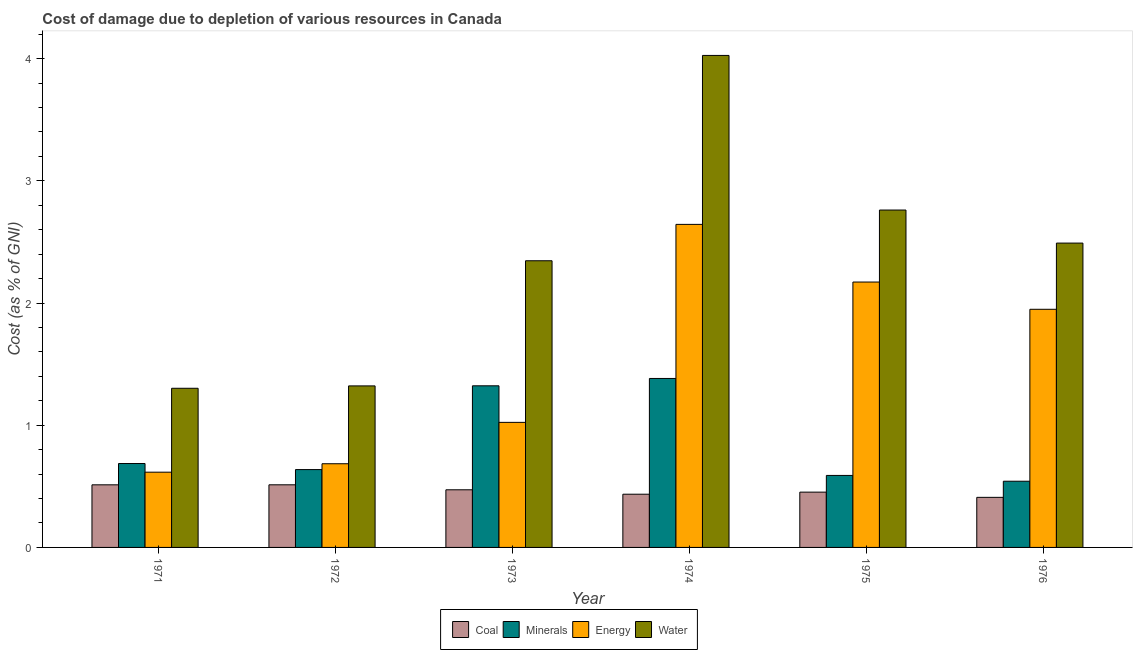How many different coloured bars are there?
Make the answer very short. 4. Are the number of bars on each tick of the X-axis equal?
Offer a very short reply. Yes. How many bars are there on the 1st tick from the left?
Your response must be concise. 4. How many bars are there on the 6th tick from the right?
Make the answer very short. 4. What is the cost of damage due to depletion of energy in 1972?
Offer a terse response. 0.68. Across all years, what is the maximum cost of damage due to depletion of energy?
Give a very brief answer. 2.64. Across all years, what is the minimum cost of damage due to depletion of water?
Provide a short and direct response. 1.3. In which year was the cost of damage due to depletion of energy maximum?
Ensure brevity in your answer.  1974. What is the total cost of damage due to depletion of water in the graph?
Make the answer very short. 14.25. What is the difference between the cost of damage due to depletion of water in 1971 and that in 1974?
Provide a short and direct response. -2.72. What is the difference between the cost of damage due to depletion of coal in 1973 and the cost of damage due to depletion of minerals in 1975?
Your answer should be very brief. 0.02. What is the average cost of damage due to depletion of minerals per year?
Offer a very short reply. 0.86. In the year 1973, what is the difference between the cost of damage due to depletion of water and cost of damage due to depletion of energy?
Make the answer very short. 0. What is the ratio of the cost of damage due to depletion of minerals in 1973 to that in 1974?
Provide a succinct answer. 0.96. What is the difference between the highest and the second highest cost of damage due to depletion of minerals?
Your response must be concise. 0.06. What is the difference between the highest and the lowest cost of damage due to depletion of energy?
Offer a very short reply. 2.03. In how many years, is the cost of damage due to depletion of coal greater than the average cost of damage due to depletion of coal taken over all years?
Make the answer very short. 3. Is the sum of the cost of damage due to depletion of water in 1973 and 1974 greater than the maximum cost of damage due to depletion of coal across all years?
Offer a terse response. Yes. What does the 1st bar from the left in 1975 represents?
Your answer should be compact. Coal. What does the 3rd bar from the right in 1973 represents?
Your answer should be very brief. Minerals. What is the difference between two consecutive major ticks on the Y-axis?
Offer a very short reply. 1. Are the values on the major ticks of Y-axis written in scientific E-notation?
Keep it short and to the point. No. Does the graph contain grids?
Offer a very short reply. No. How many legend labels are there?
Keep it short and to the point. 4. What is the title of the graph?
Keep it short and to the point. Cost of damage due to depletion of various resources in Canada . What is the label or title of the Y-axis?
Ensure brevity in your answer.  Cost (as % of GNI). What is the Cost (as % of GNI) in Coal in 1971?
Your answer should be compact. 0.51. What is the Cost (as % of GNI) in Minerals in 1971?
Make the answer very short. 0.69. What is the Cost (as % of GNI) in Energy in 1971?
Your response must be concise. 0.62. What is the Cost (as % of GNI) in Water in 1971?
Provide a succinct answer. 1.3. What is the Cost (as % of GNI) in Coal in 1972?
Ensure brevity in your answer.  0.51. What is the Cost (as % of GNI) of Minerals in 1972?
Your answer should be compact. 0.64. What is the Cost (as % of GNI) in Energy in 1972?
Your answer should be very brief. 0.68. What is the Cost (as % of GNI) in Water in 1972?
Provide a succinct answer. 1.32. What is the Cost (as % of GNI) of Coal in 1973?
Ensure brevity in your answer.  0.47. What is the Cost (as % of GNI) in Minerals in 1973?
Give a very brief answer. 1.32. What is the Cost (as % of GNI) of Energy in 1973?
Your answer should be compact. 1.02. What is the Cost (as % of GNI) in Water in 1973?
Offer a very short reply. 2.35. What is the Cost (as % of GNI) in Coal in 1974?
Offer a very short reply. 0.44. What is the Cost (as % of GNI) of Minerals in 1974?
Provide a short and direct response. 1.38. What is the Cost (as % of GNI) of Energy in 1974?
Keep it short and to the point. 2.64. What is the Cost (as % of GNI) in Water in 1974?
Make the answer very short. 4.03. What is the Cost (as % of GNI) in Coal in 1975?
Offer a very short reply. 0.45. What is the Cost (as % of GNI) of Minerals in 1975?
Keep it short and to the point. 0.59. What is the Cost (as % of GNI) in Energy in 1975?
Offer a very short reply. 2.17. What is the Cost (as % of GNI) in Water in 1975?
Ensure brevity in your answer.  2.76. What is the Cost (as % of GNI) in Coal in 1976?
Make the answer very short. 0.41. What is the Cost (as % of GNI) in Minerals in 1976?
Your answer should be very brief. 0.54. What is the Cost (as % of GNI) in Energy in 1976?
Offer a terse response. 1.95. What is the Cost (as % of GNI) of Water in 1976?
Your answer should be compact. 2.49. Across all years, what is the maximum Cost (as % of GNI) of Coal?
Provide a short and direct response. 0.51. Across all years, what is the maximum Cost (as % of GNI) in Minerals?
Ensure brevity in your answer.  1.38. Across all years, what is the maximum Cost (as % of GNI) of Energy?
Provide a succinct answer. 2.64. Across all years, what is the maximum Cost (as % of GNI) in Water?
Your response must be concise. 4.03. Across all years, what is the minimum Cost (as % of GNI) of Coal?
Provide a short and direct response. 0.41. Across all years, what is the minimum Cost (as % of GNI) in Minerals?
Your response must be concise. 0.54. Across all years, what is the minimum Cost (as % of GNI) in Energy?
Your response must be concise. 0.62. Across all years, what is the minimum Cost (as % of GNI) of Water?
Give a very brief answer. 1.3. What is the total Cost (as % of GNI) of Coal in the graph?
Ensure brevity in your answer.  2.79. What is the total Cost (as % of GNI) of Minerals in the graph?
Provide a succinct answer. 5.16. What is the total Cost (as % of GNI) in Energy in the graph?
Provide a succinct answer. 9.09. What is the total Cost (as % of GNI) of Water in the graph?
Offer a very short reply. 14.25. What is the difference between the Cost (as % of GNI) of Coal in 1971 and that in 1972?
Keep it short and to the point. -0. What is the difference between the Cost (as % of GNI) in Minerals in 1971 and that in 1972?
Your answer should be compact. 0.05. What is the difference between the Cost (as % of GNI) of Energy in 1971 and that in 1972?
Ensure brevity in your answer.  -0.07. What is the difference between the Cost (as % of GNI) in Water in 1971 and that in 1972?
Ensure brevity in your answer.  -0.02. What is the difference between the Cost (as % of GNI) in Coal in 1971 and that in 1973?
Offer a terse response. 0.04. What is the difference between the Cost (as % of GNI) in Minerals in 1971 and that in 1973?
Offer a terse response. -0.64. What is the difference between the Cost (as % of GNI) of Energy in 1971 and that in 1973?
Provide a succinct answer. -0.41. What is the difference between the Cost (as % of GNI) in Water in 1971 and that in 1973?
Provide a succinct answer. -1.04. What is the difference between the Cost (as % of GNI) of Coal in 1971 and that in 1974?
Your answer should be compact. 0.08. What is the difference between the Cost (as % of GNI) in Minerals in 1971 and that in 1974?
Give a very brief answer. -0.7. What is the difference between the Cost (as % of GNI) in Energy in 1971 and that in 1974?
Offer a terse response. -2.03. What is the difference between the Cost (as % of GNI) of Water in 1971 and that in 1974?
Keep it short and to the point. -2.72. What is the difference between the Cost (as % of GNI) of Coal in 1971 and that in 1975?
Your answer should be compact. 0.06. What is the difference between the Cost (as % of GNI) in Minerals in 1971 and that in 1975?
Make the answer very short. 0.1. What is the difference between the Cost (as % of GNI) in Energy in 1971 and that in 1975?
Give a very brief answer. -1.56. What is the difference between the Cost (as % of GNI) in Water in 1971 and that in 1975?
Your response must be concise. -1.46. What is the difference between the Cost (as % of GNI) in Coal in 1971 and that in 1976?
Make the answer very short. 0.1. What is the difference between the Cost (as % of GNI) in Minerals in 1971 and that in 1976?
Give a very brief answer. 0.14. What is the difference between the Cost (as % of GNI) of Energy in 1971 and that in 1976?
Your answer should be very brief. -1.33. What is the difference between the Cost (as % of GNI) in Water in 1971 and that in 1976?
Offer a very short reply. -1.19. What is the difference between the Cost (as % of GNI) in Coal in 1972 and that in 1973?
Give a very brief answer. 0.04. What is the difference between the Cost (as % of GNI) of Minerals in 1972 and that in 1973?
Provide a succinct answer. -0.69. What is the difference between the Cost (as % of GNI) of Energy in 1972 and that in 1973?
Give a very brief answer. -0.34. What is the difference between the Cost (as % of GNI) of Water in 1972 and that in 1973?
Provide a succinct answer. -1.02. What is the difference between the Cost (as % of GNI) of Coal in 1972 and that in 1974?
Your response must be concise. 0.08. What is the difference between the Cost (as % of GNI) of Minerals in 1972 and that in 1974?
Your answer should be very brief. -0.75. What is the difference between the Cost (as % of GNI) of Energy in 1972 and that in 1974?
Keep it short and to the point. -1.96. What is the difference between the Cost (as % of GNI) in Water in 1972 and that in 1974?
Your answer should be compact. -2.7. What is the difference between the Cost (as % of GNI) in Coal in 1972 and that in 1975?
Ensure brevity in your answer.  0.06. What is the difference between the Cost (as % of GNI) in Minerals in 1972 and that in 1975?
Your response must be concise. 0.05. What is the difference between the Cost (as % of GNI) of Energy in 1972 and that in 1975?
Keep it short and to the point. -1.49. What is the difference between the Cost (as % of GNI) of Water in 1972 and that in 1975?
Keep it short and to the point. -1.44. What is the difference between the Cost (as % of GNI) in Coal in 1972 and that in 1976?
Ensure brevity in your answer.  0.1. What is the difference between the Cost (as % of GNI) in Minerals in 1972 and that in 1976?
Ensure brevity in your answer.  0.1. What is the difference between the Cost (as % of GNI) in Energy in 1972 and that in 1976?
Ensure brevity in your answer.  -1.26. What is the difference between the Cost (as % of GNI) in Water in 1972 and that in 1976?
Provide a succinct answer. -1.17. What is the difference between the Cost (as % of GNI) of Coal in 1973 and that in 1974?
Provide a short and direct response. 0.04. What is the difference between the Cost (as % of GNI) in Minerals in 1973 and that in 1974?
Your answer should be compact. -0.06. What is the difference between the Cost (as % of GNI) of Energy in 1973 and that in 1974?
Provide a short and direct response. -1.62. What is the difference between the Cost (as % of GNI) of Water in 1973 and that in 1974?
Ensure brevity in your answer.  -1.68. What is the difference between the Cost (as % of GNI) of Coal in 1973 and that in 1975?
Your response must be concise. 0.02. What is the difference between the Cost (as % of GNI) of Minerals in 1973 and that in 1975?
Ensure brevity in your answer.  0.73. What is the difference between the Cost (as % of GNI) of Energy in 1973 and that in 1975?
Your answer should be very brief. -1.15. What is the difference between the Cost (as % of GNI) in Water in 1973 and that in 1975?
Your answer should be compact. -0.41. What is the difference between the Cost (as % of GNI) in Coal in 1973 and that in 1976?
Ensure brevity in your answer.  0.06. What is the difference between the Cost (as % of GNI) in Minerals in 1973 and that in 1976?
Your answer should be compact. 0.78. What is the difference between the Cost (as % of GNI) in Energy in 1973 and that in 1976?
Provide a succinct answer. -0.93. What is the difference between the Cost (as % of GNI) in Water in 1973 and that in 1976?
Give a very brief answer. -0.14. What is the difference between the Cost (as % of GNI) in Coal in 1974 and that in 1975?
Your answer should be very brief. -0.02. What is the difference between the Cost (as % of GNI) of Minerals in 1974 and that in 1975?
Give a very brief answer. 0.79. What is the difference between the Cost (as % of GNI) of Energy in 1974 and that in 1975?
Your response must be concise. 0.47. What is the difference between the Cost (as % of GNI) in Water in 1974 and that in 1975?
Provide a succinct answer. 1.27. What is the difference between the Cost (as % of GNI) in Coal in 1974 and that in 1976?
Your response must be concise. 0.03. What is the difference between the Cost (as % of GNI) of Minerals in 1974 and that in 1976?
Offer a terse response. 0.84. What is the difference between the Cost (as % of GNI) of Energy in 1974 and that in 1976?
Your response must be concise. 0.69. What is the difference between the Cost (as % of GNI) of Water in 1974 and that in 1976?
Make the answer very short. 1.54. What is the difference between the Cost (as % of GNI) of Coal in 1975 and that in 1976?
Offer a very short reply. 0.04. What is the difference between the Cost (as % of GNI) of Minerals in 1975 and that in 1976?
Make the answer very short. 0.05. What is the difference between the Cost (as % of GNI) in Energy in 1975 and that in 1976?
Provide a short and direct response. 0.22. What is the difference between the Cost (as % of GNI) of Water in 1975 and that in 1976?
Ensure brevity in your answer.  0.27. What is the difference between the Cost (as % of GNI) of Coal in 1971 and the Cost (as % of GNI) of Minerals in 1972?
Make the answer very short. -0.12. What is the difference between the Cost (as % of GNI) in Coal in 1971 and the Cost (as % of GNI) in Energy in 1972?
Offer a terse response. -0.17. What is the difference between the Cost (as % of GNI) of Coal in 1971 and the Cost (as % of GNI) of Water in 1972?
Your response must be concise. -0.81. What is the difference between the Cost (as % of GNI) of Minerals in 1971 and the Cost (as % of GNI) of Energy in 1972?
Provide a short and direct response. 0. What is the difference between the Cost (as % of GNI) of Minerals in 1971 and the Cost (as % of GNI) of Water in 1972?
Ensure brevity in your answer.  -0.64. What is the difference between the Cost (as % of GNI) in Energy in 1971 and the Cost (as % of GNI) in Water in 1972?
Make the answer very short. -0.71. What is the difference between the Cost (as % of GNI) of Coal in 1971 and the Cost (as % of GNI) of Minerals in 1973?
Keep it short and to the point. -0.81. What is the difference between the Cost (as % of GNI) in Coal in 1971 and the Cost (as % of GNI) in Energy in 1973?
Provide a short and direct response. -0.51. What is the difference between the Cost (as % of GNI) in Coal in 1971 and the Cost (as % of GNI) in Water in 1973?
Make the answer very short. -1.83. What is the difference between the Cost (as % of GNI) in Minerals in 1971 and the Cost (as % of GNI) in Energy in 1973?
Provide a short and direct response. -0.34. What is the difference between the Cost (as % of GNI) of Minerals in 1971 and the Cost (as % of GNI) of Water in 1973?
Ensure brevity in your answer.  -1.66. What is the difference between the Cost (as % of GNI) in Energy in 1971 and the Cost (as % of GNI) in Water in 1973?
Give a very brief answer. -1.73. What is the difference between the Cost (as % of GNI) of Coal in 1971 and the Cost (as % of GNI) of Minerals in 1974?
Offer a very short reply. -0.87. What is the difference between the Cost (as % of GNI) in Coal in 1971 and the Cost (as % of GNI) in Energy in 1974?
Make the answer very short. -2.13. What is the difference between the Cost (as % of GNI) in Coal in 1971 and the Cost (as % of GNI) in Water in 1974?
Offer a very short reply. -3.51. What is the difference between the Cost (as % of GNI) in Minerals in 1971 and the Cost (as % of GNI) in Energy in 1974?
Your response must be concise. -1.96. What is the difference between the Cost (as % of GNI) of Minerals in 1971 and the Cost (as % of GNI) of Water in 1974?
Offer a terse response. -3.34. What is the difference between the Cost (as % of GNI) in Energy in 1971 and the Cost (as % of GNI) in Water in 1974?
Give a very brief answer. -3.41. What is the difference between the Cost (as % of GNI) of Coal in 1971 and the Cost (as % of GNI) of Minerals in 1975?
Make the answer very short. -0.08. What is the difference between the Cost (as % of GNI) of Coal in 1971 and the Cost (as % of GNI) of Energy in 1975?
Your answer should be compact. -1.66. What is the difference between the Cost (as % of GNI) in Coal in 1971 and the Cost (as % of GNI) in Water in 1975?
Provide a short and direct response. -2.25. What is the difference between the Cost (as % of GNI) of Minerals in 1971 and the Cost (as % of GNI) of Energy in 1975?
Your answer should be compact. -1.49. What is the difference between the Cost (as % of GNI) of Minerals in 1971 and the Cost (as % of GNI) of Water in 1975?
Your answer should be compact. -2.07. What is the difference between the Cost (as % of GNI) of Energy in 1971 and the Cost (as % of GNI) of Water in 1975?
Offer a very short reply. -2.15. What is the difference between the Cost (as % of GNI) of Coal in 1971 and the Cost (as % of GNI) of Minerals in 1976?
Your answer should be compact. -0.03. What is the difference between the Cost (as % of GNI) in Coal in 1971 and the Cost (as % of GNI) in Energy in 1976?
Provide a short and direct response. -1.44. What is the difference between the Cost (as % of GNI) in Coal in 1971 and the Cost (as % of GNI) in Water in 1976?
Your answer should be very brief. -1.98. What is the difference between the Cost (as % of GNI) of Minerals in 1971 and the Cost (as % of GNI) of Energy in 1976?
Provide a short and direct response. -1.26. What is the difference between the Cost (as % of GNI) of Minerals in 1971 and the Cost (as % of GNI) of Water in 1976?
Keep it short and to the point. -1.8. What is the difference between the Cost (as % of GNI) of Energy in 1971 and the Cost (as % of GNI) of Water in 1976?
Your answer should be very brief. -1.87. What is the difference between the Cost (as % of GNI) of Coal in 1972 and the Cost (as % of GNI) of Minerals in 1973?
Make the answer very short. -0.81. What is the difference between the Cost (as % of GNI) of Coal in 1972 and the Cost (as % of GNI) of Energy in 1973?
Offer a very short reply. -0.51. What is the difference between the Cost (as % of GNI) in Coal in 1972 and the Cost (as % of GNI) in Water in 1973?
Offer a very short reply. -1.83. What is the difference between the Cost (as % of GNI) in Minerals in 1972 and the Cost (as % of GNI) in Energy in 1973?
Your response must be concise. -0.39. What is the difference between the Cost (as % of GNI) in Minerals in 1972 and the Cost (as % of GNI) in Water in 1973?
Ensure brevity in your answer.  -1.71. What is the difference between the Cost (as % of GNI) in Energy in 1972 and the Cost (as % of GNI) in Water in 1973?
Provide a short and direct response. -1.66. What is the difference between the Cost (as % of GNI) of Coal in 1972 and the Cost (as % of GNI) of Minerals in 1974?
Provide a short and direct response. -0.87. What is the difference between the Cost (as % of GNI) in Coal in 1972 and the Cost (as % of GNI) in Energy in 1974?
Give a very brief answer. -2.13. What is the difference between the Cost (as % of GNI) in Coal in 1972 and the Cost (as % of GNI) in Water in 1974?
Offer a terse response. -3.51. What is the difference between the Cost (as % of GNI) of Minerals in 1972 and the Cost (as % of GNI) of Energy in 1974?
Give a very brief answer. -2.01. What is the difference between the Cost (as % of GNI) in Minerals in 1972 and the Cost (as % of GNI) in Water in 1974?
Your answer should be compact. -3.39. What is the difference between the Cost (as % of GNI) of Energy in 1972 and the Cost (as % of GNI) of Water in 1974?
Offer a very short reply. -3.34. What is the difference between the Cost (as % of GNI) of Coal in 1972 and the Cost (as % of GNI) of Minerals in 1975?
Offer a terse response. -0.08. What is the difference between the Cost (as % of GNI) of Coal in 1972 and the Cost (as % of GNI) of Energy in 1975?
Your answer should be compact. -1.66. What is the difference between the Cost (as % of GNI) in Coal in 1972 and the Cost (as % of GNI) in Water in 1975?
Give a very brief answer. -2.25. What is the difference between the Cost (as % of GNI) of Minerals in 1972 and the Cost (as % of GNI) of Energy in 1975?
Make the answer very short. -1.53. What is the difference between the Cost (as % of GNI) in Minerals in 1972 and the Cost (as % of GNI) in Water in 1975?
Ensure brevity in your answer.  -2.12. What is the difference between the Cost (as % of GNI) of Energy in 1972 and the Cost (as % of GNI) of Water in 1975?
Keep it short and to the point. -2.08. What is the difference between the Cost (as % of GNI) of Coal in 1972 and the Cost (as % of GNI) of Minerals in 1976?
Offer a very short reply. -0.03. What is the difference between the Cost (as % of GNI) in Coal in 1972 and the Cost (as % of GNI) in Energy in 1976?
Give a very brief answer. -1.44. What is the difference between the Cost (as % of GNI) of Coal in 1972 and the Cost (as % of GNI) of Water in 1976?
Provide a short and direct response. -1.98. What is the difference between the Cost (as % of GNI) of Minerals in 1972 and the Cost (as % of GNI) of Energy in 1976?
Give a very brief answer. -1.31. What is the difference between the Cost (as % of GNI) of Minerals in 1972 and the Cost (as % of GNI) of Water in 1976?
Your response must be concise. -1.85. What is the difference between the Cost (as % of GNI) of Energy in 1972 and the Cost (as % of GNI) of Water in 1976?
Keep it short and to the point. -1.81. What is the difference between the Cost (as % of GNI) of Coal in 1973 and the Cost (as % of GNI) of Minerals in 1974?
Offer a very short reply. -0.91. What is the difference between the Cost (as % of GNI) of Coal in 1973 and the Cost (as % of GNI) of Energy in 1974?
Your answer should be compact. -2.17. What is the difference between the Cost (as % of GNI) of Coal in 1973 and the Cost (as % of GNI) of Water in 1974?
Give a very brief answer. -3.55. What is the difference between the Cost (as % of GNI) in Minerals in 1973 and the Cost (as % of GNI) in Energy in 1974?
Keep it short and to the point. -1.32. What is the difference between the Cost (as % of GNI) of Minerals in 1973 and the Cost (as % of GNI) of Water in 1974?
Give a very brief answer. -2.7. What is the difference between the Cost (as % of GNI) of Energy in 1973 and the Cost (as % of GNI) of Water in 1974?
Give a very brief answer. -3. What is the difference between the Cost (as % of GNI) of Coal in 1973 and the Cost (as % of GNI) of Minerals in 1975?
Make the answer very short. -0.12. What is the difference between the Cost (as % of GNI) of Coal in 1973 and the Cost (as % of GNI) of Energy in 1975?
Keep it short and to the point. -1.7. What is the difference between the Cost (as % of GNI) of Coal in 1973 and the Cost (as % of GNI) of Water in 1975?
Ensure brevity in your answer.  -2.29. What is the difference between the Cost (as % of GNI) of Minerals in 1973 and the Cost (as % of GNI) of Energy in 1975?
Your response must be concise. -0.85. What is the difference between the Cost (as % of GNI) in Minerals in 1973 and the Cost (as % of GNI) in Water in 1975?
Provide a succinct answer. -1.44. What is the difference between the Cost (as % of GNI) in Energy in 1973 and the Cost (as % of GNI) in Water in 1975?
Offer a terse response. -1.74. What is the difference between the Cost (as % of GNI) in Coal in 1973 and the Cost (as % of GNI) in Minerals in 1976?
Make the answer very short. -0.07. What is the difference between the Cost (as % of GNI) of Coal in 1973 and the Cost (as % of GNI) of Energy in 1976?
Keep it short and to the point. -1.48. What is the difference between the Cost (as % of GNI) of Coal in 1973 and the Cost (as % of GNI) of Water in 1976?
Offer a very short reply. -2.02. What is the difference between the Cost (as % of GNI) of Minerals in 1973 and the Cost (as % of GNI) of Energy in 1976?
Keep it short and to the point. -0.63. What is the difference between the Cost (as % of GNI) of Minerals in 1973 and the Cost (as % of GNI) of Water in 1976?
Make the answer very short. -1.17. What is the difference between the Cost (as % of GNI) in Energy in 1973 and the Cost (as % of GNI) in Water in 1976?
Give a very brief answer. -1.47. What is the difference between the Cost (as % of GNI) of Coal in 1974 and the Cost (as % of GNI) of Minerals in 1975?
Provide a short and direct response. -0.15. What is the difference between the Cost (as % of GNI) of Coal in 1974 and the Cost (as % of GNI) of Energy in 1975?
Your answer should be compact. -1.74. What is the difference between the Cost (as % of GNI) in Coal in 1974 and the Cost (as % of GNI) in Water in 1975?
Provide a short and direct response. -2.33. What is the difference between the Cost (as % of GNI) of Minerals in 1974 and the Cost (as % of GNI) of Energy in 1975?
Keep it short and to the point. -0.79. What is the difference between the Cost (as % of GNI) of Minerals in 1974 and the Cost (as % of GNI) of Water in 1975?
Make the answer very short. -1.38. What is the difference between the Cost (as % of GNI) of Energy in 1974 and the Cost (as % of GNI) of Water in 1975?
Provide a succinct answer. -0.12. What is the difference between the Cost (as % of GNI) of Coal in 1974 and the Cost (as % of GNI) of Minerals in 1976?
Your response must be concise. -0.11. What is the difference between the Cost (as % of GNI) of Coal in 1974 and the Cost (as % of GNI) of Energy in 1976?
Your response must be concise. -1.51. What is the difference between the Cost (as % of GNI) of Coal in 1974 and the Cost (as % of GNI) of Water in 1976?
Your response must be concise. -2.06. What is the difference between the Cost (as % of GNI) in Minerals in 1974 and the Cost (as % of GNI) in Energy in 1976?
Your answer should be compact. -0.57. What is the difference between the Cost (as % of GNI) of Minerals in 1974 and the Cost (as % of GNI) of Water in 1976?
Keep it short and to the point. -1.11. What is the difference between the Cost (as % of GNI) of Energy in 1974 and the Cost (as % of GNI) of Water in 1976?
Your response must be concise. 0.15. What is the difference between the Cost (as % of GNI) in Coal in 1975 and the Cost (as % of GNI) in Minerals in 1976?
Your answer should be very brief. -0.09. What is the difference between the Cost (as % of GNI) of Coal in 1975 and the Cost (as % of GNI) of Energy in 1976?
Keep it short and to the point. -1.5. What is the difference between the Cost (as % of GNI) of Coal in 1975 and the Cost (as % of GNI) of Water in 1976?
Give a very brief answer. -2.04. What is the difference between the Cost (as % of GNI) of Minerals in 1975 and the Cost (as % of GNI) of Energy in 1976?
Provide a short and direct response. -1.36. What is the difference between the Cost (as % of GNI) in Minerals in 1975 and the Cost (as % of GNI) in Water in 1976?
Ensure brevity in your answer.  -1.9. What is the difference between the Cost (as % of GNI) in Energy in 1975 and the Cost (as % of GNI) in Water in 1976?
Give a very brief answer. -0.32. What is the average Cost (as % of GNI) of Coal per year?
Provide a succinct answer. 0.47. What is the average Cost (as % of GNI) of Minerals per year?
Provide a succinct answer. 0.86. What is the average Cost (as % of GNI) in Energy per year?
Provide a succinct answer. 1.51. What is the average Cost (as % of GNI) of Water per year?
Keep it short and to the point. 2.37. In the year 1971, what is the difference between the Cost (as % of GNI) of Coal and Cost (as % of GNI) of Minerals?
Offer a terse response. -0.17. In the year 1971, what is the difference between the Cost (as % of GNI) of Coal and Cost (as % of GNI) of Energy?
Give a very brief answer. -0.1. In the year 1971, what is the difference between the Cost (as % of GNI) in Coal and Cost (as % of GNI) in Water?
Your response must be concise. -0.79. In the year 1971, what is the difference between the Cost (as % of GNI) of Minerals and Cost (as % of GNI) of Energy?
Offer a very short reply. 0.07. In the year 1971, what is the difference between the Cost (as % of GNI) of Minerals and Cost (as % of GNI) of Water?
Your answer should be very brief. -0.62. In the year 1971, what is the difference between the Cost (as % of GNI) in Energy and Cost (as % of GNI) in Water?
Your answer should be compact. -0.69. In the year 1972, what is the difference between the Cost (as % of GNI) in Coal and Cost (as % of GNI) in Minerals?
Offer a terse response. -0.12. In the year 1972, what is the difference between the Cost (as % of GNI) in Coal and Cost (as % of GNI) in Energy?
Your response must be concise. -0.17. In the year 1972, what is the difference between the Cost (as % of GNI) of Coal and Cost (as % of GNI) of Water?
Provide a succinct answer. -0.81. In the year 1972, what is the difference between the Cost (as % of GNI) of Minerals and Cost (as % of GNI) of Energy?
Make the answer very short. -0.05. In the year 1972, what is the difference between the Cost (as % of GNI) of Minerals and Cost (as % of GNI) of Water?
Provide a succinct answer. -0.68. In the year 1972, what is the difference between the Cost (as % of GNI) in Energy and Cost (as % of GNI) in Water?
Make the answer very short. -0.64. In the year 1973, what is the difference between the Cost (as % of GNI) in Coal and Cost (as % of GNI) in Minerals?
Provide a succinct answer. -0.85. In the year 1973, what is the difference between the Cost (as % of GNI) of Coal and Cost (as % of GNI) of Energy?
Keep it short and to the point. -0.55. In the year 1973, what is the difference between the Cost (as % of GNI) of Coal and Cost (as % of GNI) of Water?
Ensure brevity in your answer.  -1.87. In the year 1973, what is the difference between the Cost (as % of GNI) in Minerals and Cost (as % of GNI) in Energy?
Your answer should be compact. 0.3. In the year 1973, what is the difference between the Cost (as % of GNI) of Minerals and Cost (as % of GNI) of Water?
Your response must be concise. -1.02. In the year 1973, what is the difference between the Cost (as % of GNI) in Energy and Cost (as % of GNI) in Water?
Offer a terse response. -1.32. In the year 1974, what is the difference between the Cost (as % of GNI) in Coal and Cost (as % of GNI) in Minerals?
Give a very brief answer. -0.95. In the year 1974, what is the difference between the Cost (as % of GNI) in Coal and Cost (as % of GNI) in Energy?
Give a very brief answer. -2.21. In the year 1974, what is the difference between the Cost (as % of GNI) of Coal and Cost (as % of GNI) of Water?
Provide a short and direct response. -3.59. In the year 1974, what is the difference between the Cost (as % of GNI) in Minerals and Cost (as % of GNI) in Energy?
Offer a very short reply. -1.26. In the year 1974, what is the difference between the Cost (as % of GNI) in Minerals and Cost (as % of GNI) in Water?
Your response must be concise. -2.64. In the year 1974, what is the difference between the Cost (as % of GNI) of Energy and Cost (as % of GNI) of Water?
Ensure brevity in your answer.  -1.38. In the year 1975, what is the difference between the Cost (as % of GNI) of Coal and Cost (as % of GNI) of Minerals?
Provide a succinct answer. -0.14. In the year 1975, what is the difference between the Cost (as % of GNI) in Coal and Cost (as % of GNI) in Energy?
Give a very brief answer. -1.72. In the year 1975, what is the difference between the Cost (as % of GNI) in Coal and Cost (as % of GNI) in Water?
Offer a terse response. -2.31. In the year 1975, what is the difference between the Cost (as % of GNI) of Minerals and Cost (as % of GNI) of Energy?
Give a very brief answer. -1.58. In the year 1975, what is the difference between the Cost (as % of GNI) in Minerals and Cost (as % of GNI) in Water?
Make the answer very short. -2.17. In the year 1975, what is the difference between the Cost (as % of GNI) in Energy and Cost (as % of GNI) in Water?
Offer a terse response. -0.59. In the year 1976, what is the difference between the Cost (as % of GNI) in Coal and Cost (as % of GNI) in Minerals?
Give a very brief answer. -0.13. In the year 1976, what is the difference between the Cost (as % of GNI) in Coal and Cost (as % of GNI) in Energy?
Give a very brief answer. -1.54. In the year 1976, what is the difference between the Cost (as % of GNI) of Coal and Cost (as % of GNI) of Water?
Offer a terse response. -2.08. In the year 1976, what is the difference between the Cost (as % of GNI) of Minerals and Cost (as % of GNI) of Energy?
Offer a very short reply. -1.41. In the year 1976, what is the difference between the Cost (as % of GNI) of Minerals and Cost (as % of GNI) of Water?
Offer a very short reply. -1.95. In the year 1976, what is the difference between the Cost (as % of GNI) of Energy and Cost (as % of GNI) of Water?
Your response must be concise. -0.54. What is the ratio of the Cost (as % of GNI) in Coal in 1971 to that in 1972?
Provide a succinct answer. 1. What is the ratio of the Cost (as % of GNI) in Minerals in 1971 to that in 1972?
Make the answer very short. 1.08. What is the ratio of the Cost (as % of GNI) of Energy in 1971 to that in 1972?
Your response must be concise. 0.9. What is the ratio of the Cost (as % of GNI) in Water in 1971 to that in 1972?
Ensure brevity in your answer.  0.99. What is the ratio of the Cost (as % of GNI) in Coal in 1971 to that in 1973?
Your response must be concise. 1.09. What is the ratio of the Cost (as % of GNI) of Minerals in 1971 to that in 1973?
Give a very brief answer. 0.52. What is the ratio of the Cost (as % of GNI) in Energy in 1971 to that in 1973?
Make the answer very short. 0.6. What is the ratio of the Cost (as % of GNI) of Water in 1971 to that in 1973?
Offer a terse response. 0.56. What is the ratio of the Cost (as % of GNI) in Coal in 1971 to that in 1974?
Offer a terse response. 1.18. What is the ratio of the Cost (as % of GNI) of Minerals in 1971 to that in 1974?
Offer a very short reply. 0.5. What is the ratio of the Cost (as % of GNI) in Energy in 1971 to that in 1974?
Your answer should be compact. 0.23. What is the ratio of the Cost (as % of GNI) of Water in 1971 to that in 1974?
Keep it short and to the point. 0.32. What is the ratio of the Cost (as % of GNI) of Coal in 1971 to that in 1975?
Offer a very short reply. 1.13. What is the ratio of the Cost (as % of GNI) in Minerals in 1971 to that in 1975?
Offer a terse response. 1.17. What is the ratio of the Cost (as % of GNI) of Energy in 1971 to that in 1975?
Offer a very short reply. 0.28. What is the ratio of the Cost (as % of GNI) in Water in 1971 to that in 1975?
Ensure brevity in your answer.  0.47. What is the ratio of the Cost (as % of GNI) in Coal in 1971 to that in 1976?
Keep it short and to the point. 1.25. What is the ratio of the Cost (as % of GNI) of Minerals in 1971 to that in 1976?
Your answer should be compact. 1.27. What is the ratio of the Cost (as % of GNI) of Energy in 1971 to that in 1976?
Offer a terse response. 0.32. What is the ratio of the Cost (as % of GNI) in Water in 1971 to that in 1976?
Make the answer very short. 0.52. What is the ratio of the Cost (as % of GNI) in Coal in 1972 to that in 1973?
Provide a succinct answer. 1.09. What is the ratio of the Cost (as % of GNI) of Minerals in 1972 to that in 1973?
Your response must be concise. 0.48. What is the ratio of the Cost (as % of GNI) in Energy in 1972 to that in 1973?
Make the answer very short. 0.67. What is the ratio of the Cost (as % of GNI) in Water in 1972 to that in 1973?
Your answer should be very brief. 0.56. What is the ratio of the Cost (as % of GNI) in Coal in 1972 to that in 1974?
Your response must be concise. 1.18. What is the ratio of the Cost (as % of GNI) in Minerals in 1972 to that in 1974?
Make the answer very short. 0.46. What is the ratio of the Cost (as % of GNI) in Energy in 1972 to that in 1974?
Ensure brevity in your answer.  0.26. What is the ratio of the Cost (as % of GNI) in Water in 1972 to that in 1974?
Your answer should be very brief. 0.33. What is the ratio of the Cost (as % of GNI) of Coal in 1972 to that in 1975?
Offer a terse response. 1.13. What is the ratio of the Cost (as % of GNI) of Minerals in 1972 to that in 1975?
Provide a short and direct response. 1.08. What is the ratio of the Cost (as % of GNI) of Energy in 1972 to that in 1975?
Ensure brevity in your answer.  0.32. What is the ratio of the Cost (as % of GNI) of Water in 1972 to that in 1975?
Provide a succinct answer. 0.48. What is the ratio of the Cost (as % of GNI) of Coal in 1972 to that in 1976?
Your answer should be very brief. 1.25. What is the ratio of the Cost (as % of GNI) in Minerals in 1972 to that in 1976?
Offer a very short reply. 1.18. What is the ratio of the Cost (as % of GNI) of Energy in 1972 to that in 1976?
Your answer should be very brief. 0.35. What is the ratio of the Cost (as % of GNI) of Water in 1972 to that in 1976?
Provide a short and direct response. 0.53. What is the ratio of the Cost (as % of GNI) in Coal in 1973 to that in 1974?
Your answer should be very brief. 1.08. What is the ratio of the Cost (as % of GNI) in Minerals in 1973 to that in 1974?
Provide a succinct answer. 0.96. What is the ratio of the Cost (as % of GNI) in Energy in 1973 to that in 1974?
Your response must be concise. 0.39. What is the ratio of the Cost (as % of GNI) of Water in 1973 to that in 1974?
Provide a succinct answer. 0.58. What is the ratio of the Cost (as % of GNI) in Coal in 1973 to that in 1975?
Offer a terse response. 1.04. What is the ratio of the Cost (as % of GNI) in Minerals in 1973 to that in 1975?
Offer a very short reply. 2.24. What is the ratio of the Cost (as % of GNI) of Energy in 1973 to that in 1975?
Ensure brevity in your answer.  0.47. What is the ratio of the Cost (as % of GNI) in Water in 1973 to that in 1975?
Offer a very short reply. 0.85. What is the ratio of the Cost (as % of GNI) in Coal in 1973 to that in 1976?
Provide a short and direct response. 1.15. What is the ratio of the Cost (as % of GNI) of Minerals in 1973 to that in 1976?
Offer a very short reply. 2.44. What is the ratio of the Cost (as % of GNI) of Energy in 1973 to that in 1976?
Make the answer very short. 0.53. What is the ratio of the Cost (as % of GNI) of Water in 1973 to that in 1976?
Provide a short and direct response. 0.94. What is the ratio of the Cost (as % of GNI) in Coal in 1974 to that in 1975?
Offer a very short reply. 0.96. What is the ratio of the Cost (as % of GNI) in Minerals in 1974 to that in 1975?
Ensure brevity in your answer.  2.35. What is the ratio of the Cost (as % of GNI) of Energy in 1974 to that in 1975?
Give a very brief answer. 1.22. What is the ratio of the Cost (as % of GNI) in Water in 1974 to that in 1975?
Give a very brief answer. 1.46. What is the ratio of the Cost (as % of GNI) of Coal in 1974 to that in 1976?
Provide a short and direct response. 1.06. What is the ratio of the Cost (as % of GNI) of Minerals in 1974 to that in 1976?
Ensure brevity in your answer.  2.55. What is the ratio of the Cost (as % of GNI) in Energy in 1974 to that in 1976?
Make the answer very short. 1.36. What is the ratio of the Cost (as % of GNI) of Water in 1974 to that in 1976?
Ensure brevity in your answer.  1.62. What is the ratio of the Cost (as % of GNI) of Coal in 1975 to that in 1976?
Give a very brief answer. 1.1. What is the ratio of the Cost (as % of GNI) in Minerals in 1975 to that in 1976?
Ensure brevity in your answer.  1.09. What is the ratio of the Cost (as % of GNI) of Energy in 1975 to that in 1976?
Keep it short and to the point. 1.11. What is the ratio of the Cost (as % of GNI) in Water in 1975 to that in 1976?
Your answer should be very brief. 1.11. What is the difference between the highest and the second highest Cost (as % of GNI) in Minerals?
Keep it short and to the point. 0.06. What is the difference between the highest and the second highest Cost (as % of GNI) in Energy?
Keep it short and to the point. 0.47. What is the difference between the highest and the second highest Cost (as % of GNI) of Water?
Your response must be concise. 1.27. What is the difference between the highest and the lowest Cost (as % of GNI) of Coal?
Your answer should be compact. 0.1. What is the difference between the highest and the lowest Cost (as % of GNI) in Minerals?
Your answer should be compact. 0.84. What is the difference between the highest and the lowest Cost (as % of GNI) of Energy?
Make the answer very short. 2.03. What is the difference between the highest and the lowest Cost (as % of GNI) of Water?
Your answer should be very brief. 2.72. 